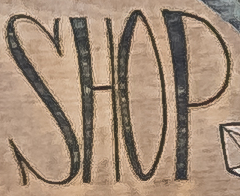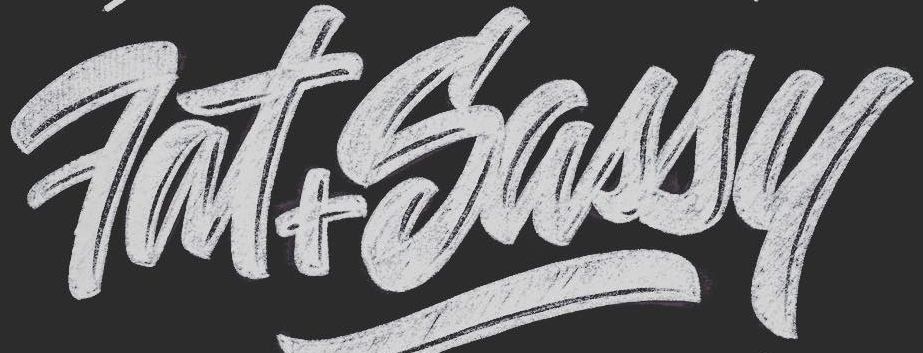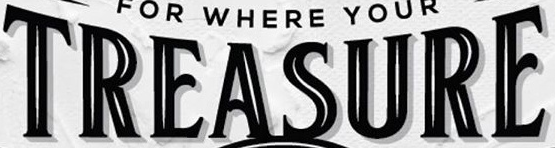Transcribe the words shown in these images in order, separated by a semicolon. SHOP; Fat+Sassy; TREASURE 